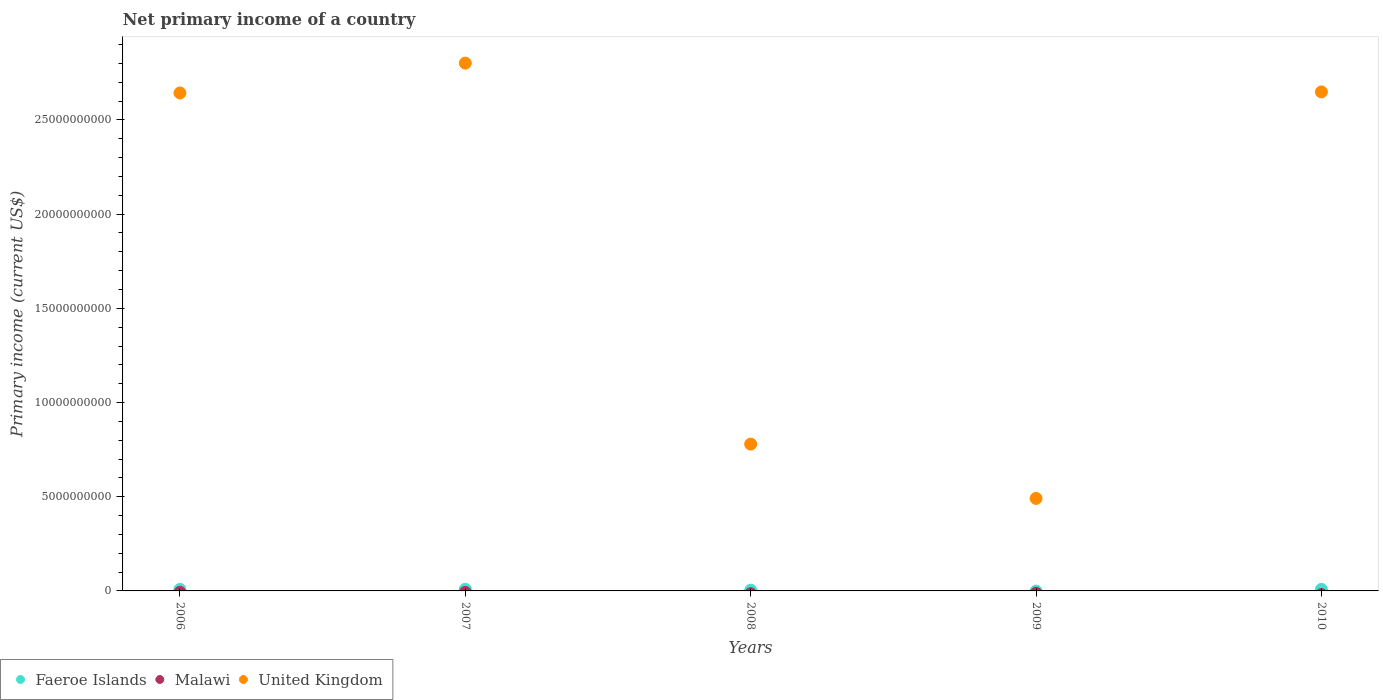How many different coloured dotlines are there?
Offer a terse response. 2. Is the number of dotlines equal to the number of legend labels?
Make the answer very short. No. What is the primary income in Malawi in 2008?
Offer a terse response. 0. Across all years, what is the maximum primary income in United Kingdom?
Ensure brevity in your answer.  2.80e+1. Across all years, what is the minimum primary income in United Kingdom?
Your answer should be compact. 4.91e+09. In which year was the primary income in Faeroe Islands maximum?
Provide a succinct answer. 2007. What is the difference between the primary income in Faeroe Islands in 2006 and that in 2007?
Your response must be concise. -7.85e+06. What is the difference between the primary income in United Kingdom in 2007 and the primary income in Faeroe Islands in 2010?
Your answer should be compact. 2.79e+1. What is the average primary income in United Kingdom per year?
Give a very brief answer. 1.87e+1. In the year 2006, what is the difference between the primary income in Faeroe Islands and primary income in United Kingdom?
Ensure brevity in your answer.  -2.64e+1. What is the ratio of the primary income in Faeroe Islands in 2007 to that in 2010?
Your response must be concise. 1.06. What is the difference between the highest and the second highest primary income in United Kingdom?
Make the answer very short. 1.53e+09. What is the difference between the highest and the lowest primary income in Faeroe Islands?
Provide a short and direct response. 8.82e+07. Is the sum of the primary income in Faeroe Islands in 2006 and 2007 greater than the maximum primary income in Malawi across all years?
Your response must be concise. Yes. Is it the case that in every year, the sum of the primary income in Malawi and primary income in Faeroe Islands  is greater than the primary income in United Kingdom?
Your answer should be very brief. No. Does the primary income in United Kingdom monotonically increase over the years?
Your answer should be very brief. No. Is the primary income in Malawi strictly greater than the primary income in United Kingdom over the years?
Make the answer very short. No. How many years are there in the graph?
Your answer should be compact. 5. How are the legend labels stacked?
Provide a succinct answer. Horizontal. What is the title of the graph?
Provide a succinct answer. Net primary income of a country. What is the label or title of the Y-axis?
Make the answer very short. Primary income (current US$). What is the Primary income (current US$) of Faeroe Islands in 2006?
Make the answer very short. 8.03e+07. What is the Primary income (current US$) in Malawi in 2006?
Offer a terse response. 0. What is the Primary income (current US$) in United Kingdom in 2006?
Give a very brief answer. 2.64e+1. What is the Primary income (current US$) in Faeroe Islands in 2007?
Your answer should be compact. 8.82e+07. What is the Primary income (current US$) in United Kingdom in 2007?
Provide a short and direct response. 2.80e+1. What is the Primary income (current US$) of Faeroe Islands in 2008?
Offer a very short reply. 3.95e+07. What is the Primary income (current US$) of United Kingdom in 2008?
Ensure brevity in your answer.  7.79e+09. What is the Primary income (current US$) in Faeroe Islands in 2009?
Offer a very short reply. 0. What is the Primary income (current US$) in United Kingdom in 2009?
Give a very brief answer. 4.91e+09. What is the Primary income (current US$) of Faeroe Islands in 2010?
Your answer should be very brief. 8.32e+07. What is the Primary income (current US$) of Malawi in 2010?
Keep it short and to the point. 0. What is the Primary income (current US$) of United Kingdom in 2010?
Offer a terse response. 2.65e+1. Across all years, what is the maximum Primary income (current US$) in Faeroe Islands?
Give a very brief answer. 8.82e+07. Across all years, what is the maximum Primary income (current US$) of United Kingdom?
Your answer should be compact. 2.80e+1. Across all years, what is the minimum Primary income (current US$) in United Kingdom?
Make the answer very short. 4.91e+09. What is the total Primary income (current US$) in Faeroe Islands in the graph?
Make the answer very short. 2.91e+08. What is the total Primary income (current US$) of Malawi in the graph?
Your answer should be very brief. 0. What is the total Primary income (current US$) in United Kingdom in the graph?
Your answer should be compact. 9.36e+1. What is the difference between the Primary income (current US$) of Faeroe Islands in 2006 and that in 2007?
Provide a succinct answer. -7.85e+06. What is the difference between the Primary income (current US$) in United Kingdom in 2006 and that in 2007?
Make the answer very short. -1.58e+09. What is the difference between the Primary income (current US$) in Faeroe Islands in 2006 and that in 2008?
Offer a terse response. 4.08e+07. What is the difference between the Primary income (current US$) of United Kingdom in 2006 and that in 2008?
Keep it short and to the point. 1.86e+1. What is the difference between the Primary income (current US$) of United Kingdom in 2006 and that in 2009?
Ensure brevity in your answer.  2.15e+1. What is the difference between the Primary income (current US$) of Faeroe Islands in 2006 and that in 2010?
Keep it short and to the point. -2.93e+06. What is the difference between the Primary income (current US$) of United Kingdom in 2006 and that in 2010?
Your answer should be very brief. -5.57e+07. What is the difference between the Primary income (current US$) in Faeroe Islands in 2007 and that in 2008?
Give a very brief answer. 4.86e+07. What is the difference between the Primary income (current US$) in United Kingdom in 2007 and that in 2008?
Make the answer very short. 2.02e+1. What is the difference between the Primary income (current US$) in United Kingdom in 2007 and that in 2009?
Provide a succinct answer. 2.31e+1. What is the difference between the Primary income (current US$) in Faeroe Islands in 2007 and that in 2010?
Offer a terse response. 4.93e+06. What is the difference between the Primary income (current US$) of United Kingdom in 2007 and that in 2010?
Ensure brevity in your answer.  1.53e+09. What is the difference between the Primary income (current US$) in United Kingdom in 2008 and that in 2009?
Give a very brief answer. 2.88e+09. What is the difference between the Primary income (current US$) in Faeroe Islands in 2008 and that in 2010?
Offer a terse response. -4.37e+07. What is the difference between the Primary income (current US$) in United Kingdom in 2008 and that in 2010?
Your answer should be compact. -1.87e+1. What is the difference between the Primary income (current US$) of United Kingdom in 2009 and that in 2010?
Offer a very short reply. -2.16e+1. What is the difference between the Primary income (current US$) in Faeroe Islands in 2006 and the Primary income (current US$) in United Kingdom in 2007?
Your answer should be compact. -2.79e+1. What is the difference between the Primary income (current US$) in Faeroe Islands in 2006 and the Primary income (current US$) in United Kingdom in 2008?
Ensure brevity in your answer.  -7.71e+09. What is the difference between the Primary income (current US$) of Faeroe Islands in 2006 and the Primary income (current US$) of United Kingdom in 2009?
Offer a terse response. -4.83e+09. What is the difference between the Primary income (current US$) of Faeroe Islands in 2006 and the Primary income (current US$) of United Kingdom in 2010?
Keep it short and to the point. -2.64e+1. What is the difference between the Primary income (current US$) in Faeroe Islands in 2007 and the Primary income (current US$) in United Kingdom in 2008?
Keep it short and to the point. -7.71e+09. What is the difference between the Primary income (current US$) of Faeroe Islands in 2007 and the Primary income (current US$) of United Kingdom in 2009?
Give a very brief answer. -4.82e+09. What is the difference between the Primary income (current US$) of Faeroe Islands in 2007 and the Primary income (current US$) of United Kingdom in 2010?
Provide a short and direct response. -2.64e+1. What is the difference between the Primary income (current US$) of Faeroe Islands in 2008 and the Primary income (current US$) of United Kingdom in 2009?
Offer a very short reply. -4.87e+09. What is the difference between the Primary income (current US$) in Faeroe Islands in 2008 and the Primary income (current US$) in United Kingdom in 2010?
Your response must be concise. -2.64e+1. What is the average Primary income (current US$) of Faeroe Islands per year?
Keep it short and to the point. 5.82e+07. What is the average Primary income (current US$) in United Kingdom per year?
Your response must be concise. 1.87e+1. In the year 2006, what is the difference between the Primary income (current US$) in Faeroe Islands and Primary income (current US$) in United Kingdom?
Provide a short and direct response. -2.64e+1. In the year 2007, what is the difference between the Primary income (current US$) in Faeroe Islands and Primary income (current US$) in United Kingdom?
Keep it short and to the point. -2.79e+1. In the year 2008, what is the difference between the Primary income (current US$) of Faeroe Islands and Primary income (current US$) of United Kingdom?
Provide a succinct answer. -7.75e+09. In the year 2010, what is the difference between the Primary income (current US$) of Faeroe Islands and Primary income (current US$) of United Kingdom?
Offer a terse response. -2.64e+1. What is the ratio of the Primary income (current US$) in Faeroe Islands in 2006 to that in 2007?
Provide a short and direct response. 0.91. What is the ratio of the Primary income (current US$) of United Kingdom in 2006 to that in 2007?
Your answer should be compact. 0.94. What is the ratio of the Primary income (current US$) of Faeroe Islands in 2006 to that in 2008?
Your answer should be compact. 2.03. What is the ratio of the Primary income (current US$) of United Kingdom in 2006 to that in 2008?
Your answer should be compact. 3.39. What is the ratio of the Primary income (current US$) of United Kingdom in 2006 to that in 2009?
Your response must be concise. 5.38. What is the ratio of the Primary income (current US$) of Faeroe Islands in 2006 to that in 2010?
Provide a short and direct response. 0.96. What is the ratio of the Primary income (current US$) of Faeroe Islands in 2007 to that in 2008?
Offer a very short reply. 2.23. What is the ratio of the Primary income (current US$) in United Kingdom in 2007 to that in 2008?
Give a very brief answer. 3.59. What is the ratio of the Primary income (current US$) of United Kingdom in 2007 to that in 2009?
Your answer should be very brief. 5.71. What is the ratio of the Primary income (current US$) in Faeroe Islands in 2007 to that in 2010?
Offer a terse response. 1.06. What is the ratio of the Primary income (current US$) of United Kingdom in 2007 to that in 2010?
Give a very brief answer. 1.06. What is the ratio of the Primary income (current US$) of United Kingdom in 2008 to that in 2009?
Provide a short and direct response. 1.59. What is the ratio of the Primary income (current US$) of Faeroe Islands in 2008 to that in 2010?
Offer a terse response. 0.47. What is the ratio of the Primary income (current US$) in United Kingdom in 2008 to that in 2010?
Give a very brief answer. 0.29. What is the ratio of the Primary income (current US$) of United Kingdom in 2009 to that in 2010?
Your response must be concise. 0.19. What is the difference between the highest and the second highest Primary income (current US$) in Faeroe Islands?
Make the answer very short. 4.93e+06. What is the difference between the highest and the second highest Primary income (current US$) in United Kingdom?
Your response must be concise. 1.53e+09. What is the difference between the highest and the lowest Primary income (current US$) of Faeroe Islands?
Provide a succinct answer. 8.82e+07. What is the difference between the highest and the lowest Primary income (current US$) of United Kingdom?
Provide a succinct answer. 2.31e+1. 